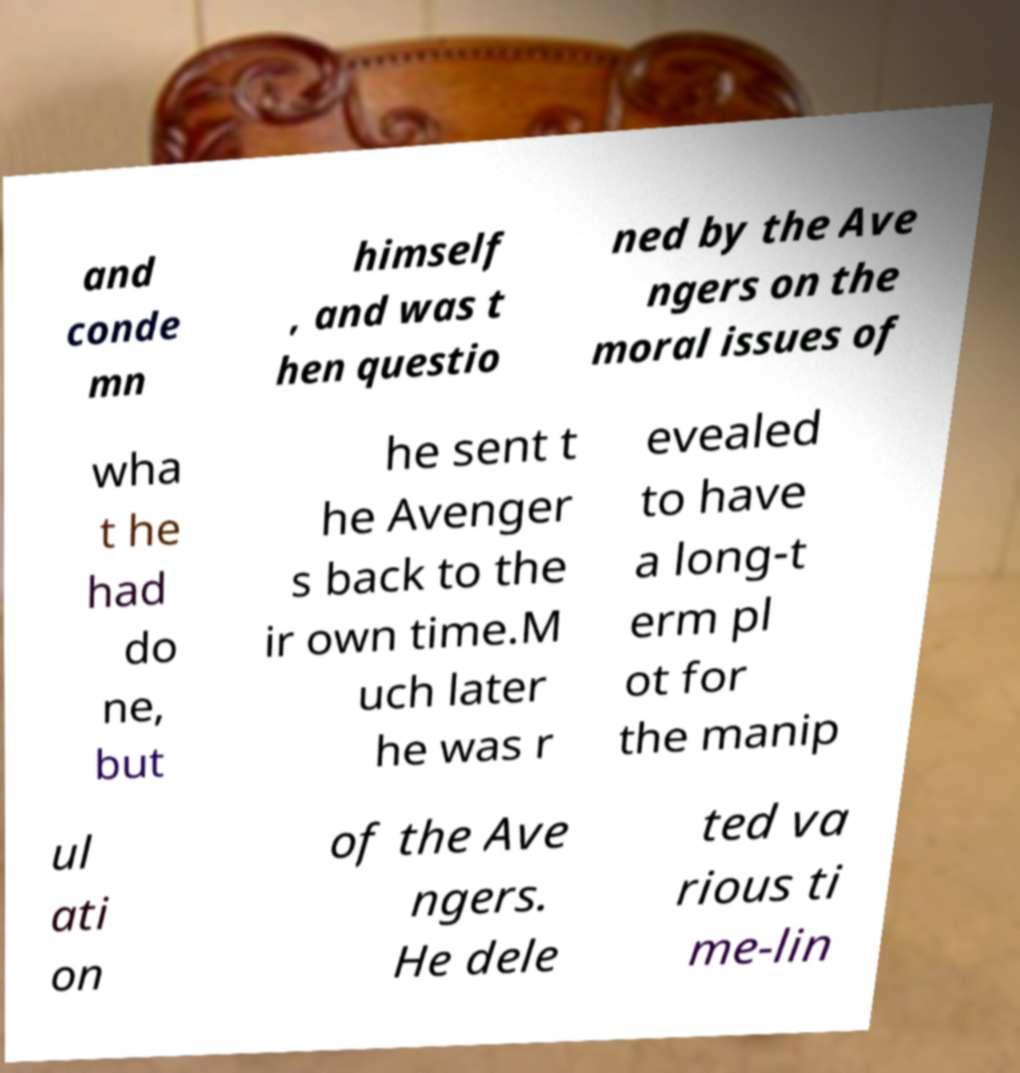What messages or text are displayed in this image? I need them in a readable, typed format. and conde mn himself , and was t hen questio ned by the Ave ngers on the moral issues of wha t he had do ne, but he sent t he Avenger s back to the ir own time.M uch later he was r evealed to have a long-t erm pl ot for the manip ul ati on of the Ave ngers. He dele ted va rious ti me-lin 